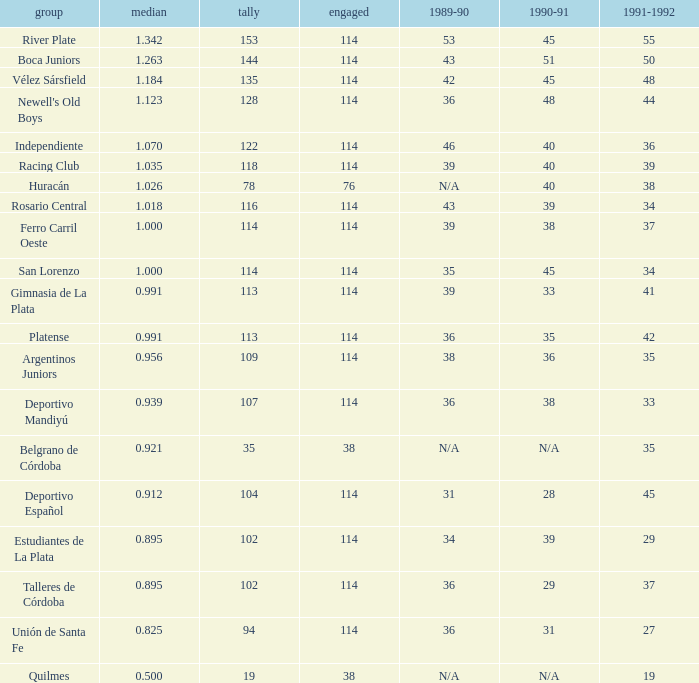Give me the full table as a dictionary. {'header': ['group', 'median', 'tally', 'engaged', '1989-90', '1990-91', '1991-1992'], 'rows': [['River Plate', '1.342', '153', '114', '53', '45', '55'], ['Boca Juniors', '1.263', '144', '114', '43', '51', '50'], ['Vélez Sársfield', '1.184', '135', '114', '42', '45', '48'], ["Newell's Old Boys", '1.123', '128', '114', '36', '48', '44'], ['Independiente', '1.070', '122', '114', '46', '40', '36'], ['Racing Club', '1.035', '118', '114', '39', '40', '39'], ['Huracán', '1.026', '78', '76', 'N/A', '40', '38'], ['Rosario Central', '1.018', '116', '114', '43', '39', '34'], ['Ferro Carril Oeste', '1.000', '114', '114', '39', '38', '37'], ['San Lorenzo', '1.000', '114', '114', '35', '45', '34'], ['Gimnasia de La Plata', '0.991', '113', '114', '39', '33', '41'], ['Platense', '0.991', '113', '114', '36', '35', '42'], ['Argentinos Juniors', '0.956', '109', '114', '38', '36', '35'], ['Deportivo Mandiyú', '0.939', '107', '114', '36', '38', '33'], ['Belgrano de Córdoba', '0.921', '35', '38', 'N/A', 'N/A', '35'], ['Deportivo Español', '0.912', '104', '114', '31', '28', '45'], ['Estudiantes de La Plata', '0.895', '102', '114', '34', '39', '29'], ['Talleres de Córdoba', '0.895', '102', '114', '36', '29', '37'], ['Unión de Santa Fe', '0.825', '94', '114', '36', '31', '27'], ['Quilmes', '0.500', '19', '38', 'N/A', 'N/A', '19']]} How much 1991-1992 has a 1989-90 of 36, and an Average of 0.8250000000000001? 0.0. 